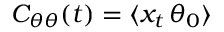<formula> <loc_0><loc_0><loc_500><loc_500>C _ { \theta \theta } ( t ) = \langle x _ { t } \, \theta _ { 0 } \rangle</formula> 